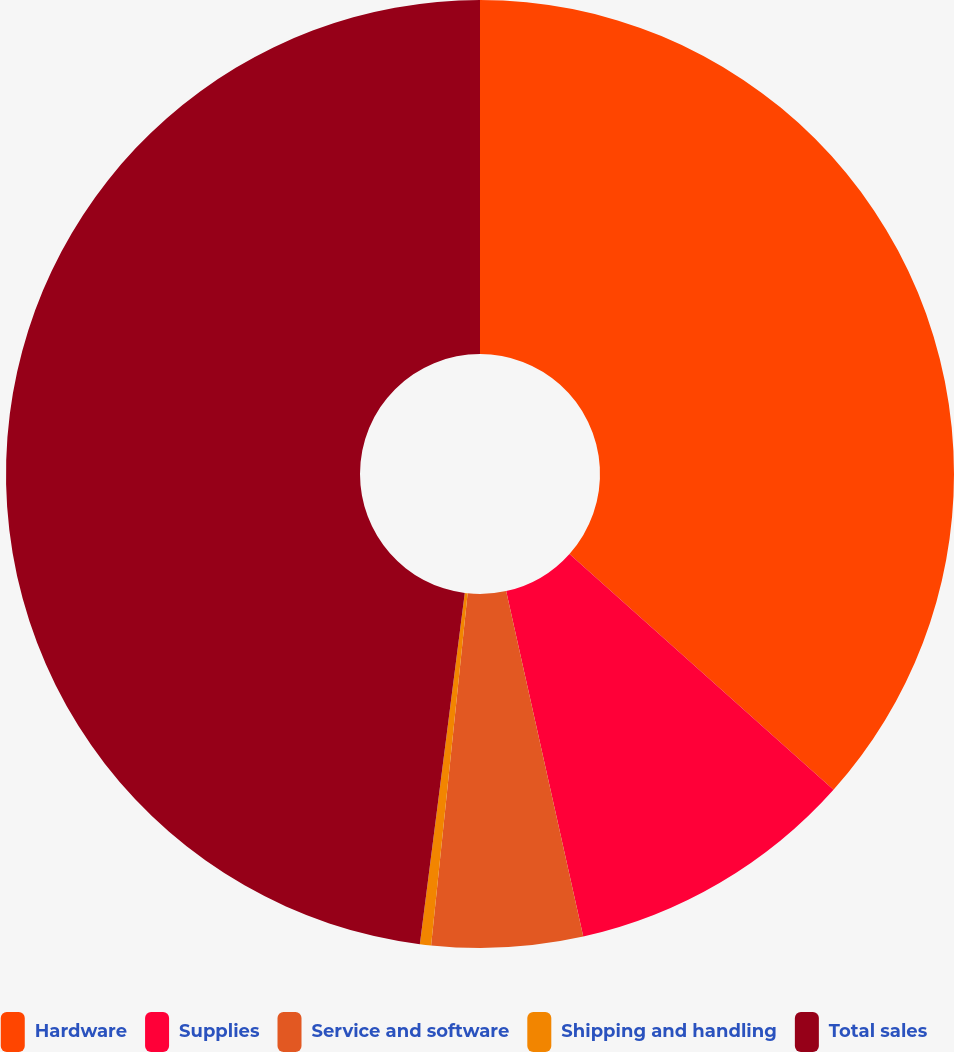Convert chart to OTSL. <chart><loc_0><loc_0><loc_500><loc_500><pie_chart><fcel>Hardware<fcel>Supplies<fcel>Service and software<fcel>Shipping and handling<fcel>Total sales<nl><fcel>36.6%<fcel>9.9%<fcel>5.14%<fcel>0.38%<fcel>47.97%<nl></chart> 